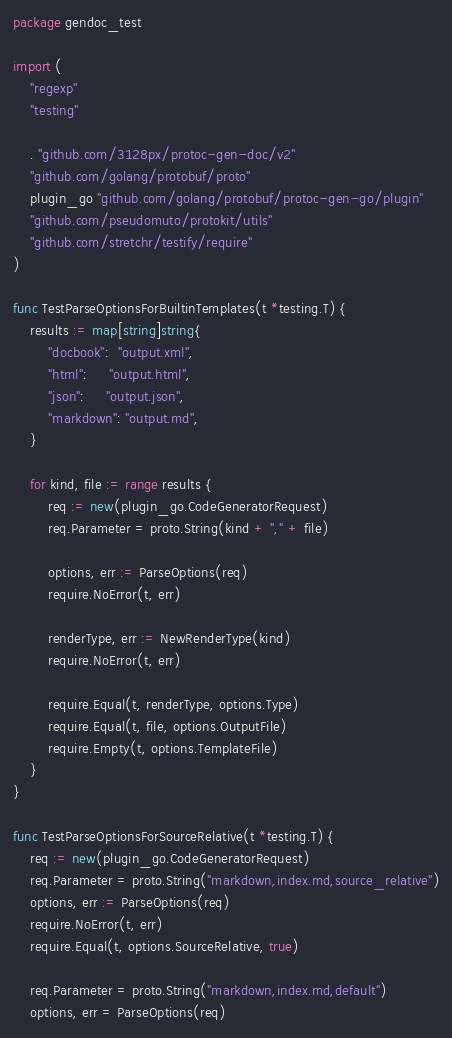<code> <loc_0><loc_0><loc_500><loc_500><_Go_>package gendoc_test

import (
	"regexp"
	"testing"

	. "github.com/3128px/protoc-gen-doc/v2"
	"github.com/golang/protobuf/proto"
	plugin_go "github.com/golang/protobuf/protoc-gen-go/plugin"
	"github.com/pseudomuto/protokit/utils"
	"github.com/stretchr/testify/require"
)

func TestParseOptionsForBuiltinTemplates(t *testing.T) {
	results := map[string]string{
		"docbook":  "output.xml",
		"html":     "output.html",
		"json":     "output.json",
		"markdown": "output.md",
	}

	for kind, file := range results {
		req := new(plugin_go.CodeGeneratorRequest)
		req.Parameter = proto.String(kind + "," + file)

		options, err := ParseOptions(req)
		require.NoError(t, err)

		renderType, err := NewRenderType(kind)
		require.NoError(t, err)

		require.Equal(t, renderType, options.Type)
		require.Equal(t, file, options.OutputFile)
		require.Empty(t, options.TemplateFile)
	}
}

func TestParseOptionsForSourceRelative(t *testing.T) {
	req := new(plugin_go.CodeGeneratorRequest)
	req.Parameter = proto.String("markdown,index.md,source_relative")
	options, err := ParseOptions(req)
	require.NoError(t, err)
	require.Equal(t, options.SourceRelative, true)

	req.Parameter = proto.String("markdown,index.md,default")
	options, err = ParseOptions(req)</code> 